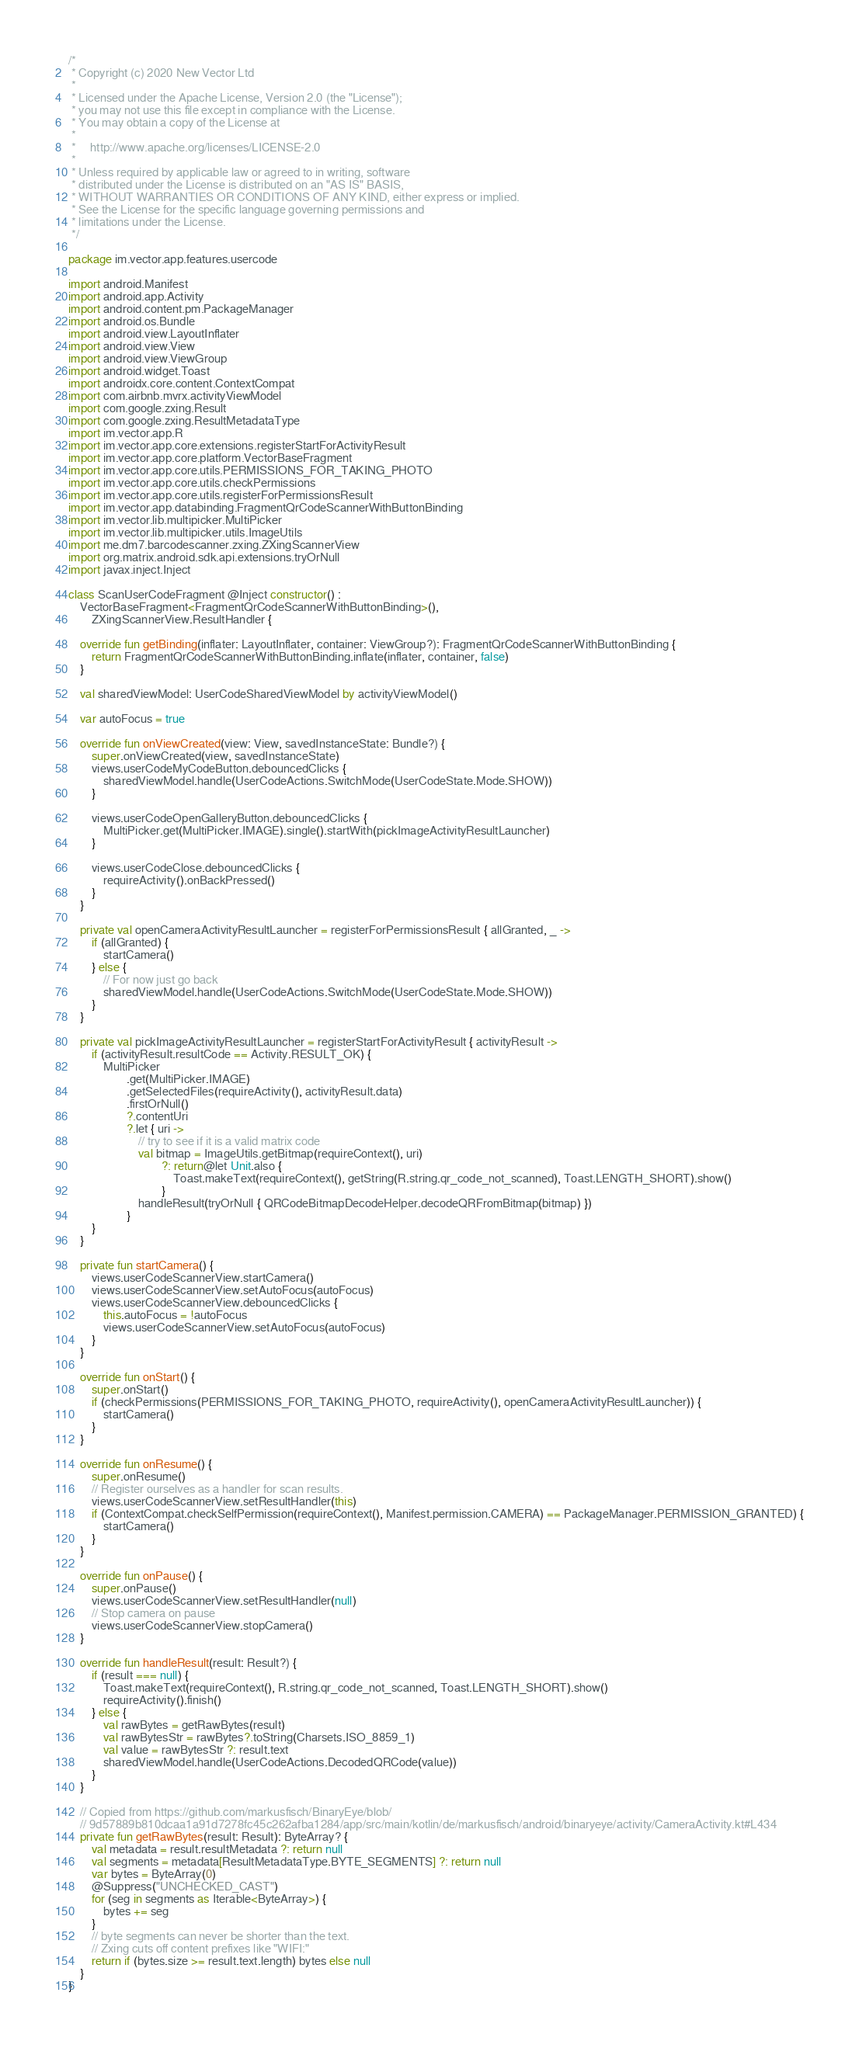<code> <loc_0><loc_0><loc_500><loc_500><_Kotlin_>/*
 * Copyright (c) 2020 New Vector Ltd
 *
 * Licensed under the Apache License, Version 2.0 (the "License");
 * you may not use this file except in compliance with the License.
 * You may obtain a copy of the License at
 *
 *     http://www.apache.org/licenses/LICENSE-2.0
 *
 * Unless required by applicable law or agreed to in writing, software
 * distributed under the License is distributed on an "AS IS" BASIS,
 * WITHOUT WARRANTIES OR CONDITIONS OF ANY KIND, either express or implied.
 * See the License for the specific language governing permissions and
 * limitations under the License.
 */

package im.vector.app.features.usercode

import android.Manifest
import android.app.Activity
import android.content.pm.PackageManager
import android.os.Bundle
import android.view.LayoutInflater
import android.view.View
import android.view.ViewGroup
import android.widget.Toast
import androidx.core.content.ContextCompat
import com.airbnb.mvrx.activityViewModel
import com.google.zxing.Result
import com.google.zxing.ResultMetadataType
import im.vector.app.R
import im.vector.app.core.extensions.registerStartForActivityResult
import im.vector.app.core.platform.VectorBaseFragment
import im.vector.app.core.utils.PERMISSIONS_FOR_TAKING_PHOTO
import im.vector.app.core.utils.checkPermissions
import im.vector.app.core.utils.registerForPermissionsResult
import im.vector.app.databinding.FragmentQrCodeScannerWithButtonBinding
import im.vector.lib.multipicker.MultiPicker
import im.vector.lib.multipicker.utils.ImageUtils
import me.dm7.barcodescanner.zxing.ZXingScannerView
import org.matrix.android.sdk.api.extensions.tryOrNull
import javax.inject.Inject

class ScanUserCodeFragment @Inject constructor() :
    VectorBaseFragment<FragmentQrCodeScannerWithButtonBinding>(),
        ZXingScannerView.ResultHandler {

    override fun getBinding(inflater: LayoutInflater, container: ViewGroup?): FragmentQrCodeScannerWithButtonBinding {
        return FragmentQrCodeScannerWithButtonBinding.inflate(inflater, container, false)
    }

    val sharedViewModel: UserCodeSharedViewModel by activityViewModel()

    var autoFocus = true

    override fun onViewCreated(view: View, savedInstanceState: Bundle?) {
        super.onViewCreated(view, savedInstanceState)
        views.userCodeMyCodeButton.debouncedClicks {
            sharedViewModel.handle(UserCodeActions.SwitchMode(UserCodeState.Mode.SHOW))
        }

        views.userCodeOpenGalleryButton.debouncedClicks {
            MultiPicker.get(MultiPicker.IMAGE).single().startWith(pickImageActivityResultLauncher)
        }

        views.userCodeClose.debouncedClicks {
            requireActivity().onBackPressed()
        }
    }

    private val openCameraActivityResultLauncher = registerForPermissionsResult { allGranted, _ ->
        if (allGranted) {
            startCamera()
        } else {
            // For now just go back
            sharedViewModel.handle(UserCodeActions.SwitchMode(UserCodeState.Mode.SHOW))
        }
    }

    private val pickImageActivityResultLauncher = registerStartForActivityResult { activityResult ->
        if (activityResult.resultCode == Activity.RESULT_OK) {
            MultiPicker
                    .get(MultiPicker.IMAGE)
                    .getSelectedFiles(requireActivity(), activityResult.data)
                    .firstOrNull()
                    ?.contentUri
                    ?.let { uri ->
                        // try to see if it is a valid matrix code
                        val bitmap = ImageUtils.getBitmap(requireContext(), uri)
                                ?: return@let Unit.also {
                                    Toast.makeText(requireContext(), getString(R.string.qr_code_not_scanned), Toast.LENGTH_SHORT).show()
                                }
                        handleResult(tryOrNull { QRCodeBitmapDecodeHelper.decodeQRFromBitmap(bitmap) })
                    }
        }
    }

    private fun startCamera() {
        views.userCodeScannerView.startCamera()
        views.userCodeScannerView.setAutoFocus(autoFocus)
        views.userCodeScannerView.debouncedClicks {
            this.autoFocus = !autoFocus
            views.userCodeScannerView.setAutoFocus(autoFocus)
        }
    }

    override fun onStart() {
        super.onStart()
        if (checkPermissions(PERMISSIONS_FOR_TAKING_PHOTO, requireActivity(), openCameraActivityResultLauncher)) {
            startCamera()
        }
    }

    override fun onResume() {
        super.onResume()
        // Register ourselves as a handler for scan results.
        views.userCodeScannerView.setResultHandler(this)
        if (ContextCompat.checkSelfPermission(requireContext(), Manifest.permission.CAMERA) == PackageManager.PERMISSION_GRANTED) {
            startCamera()
        }
    }

    override fun onPause() {
        super.onPause()
        views.userCodeScannerView.setResultHandler(null)
        // Stop camera on pause
        views.userCodeScannerView.stopCamera()
    }

    override fun handleResult(result: Result?) {
        if (result === null) {
            Toast.makeText(requireContext(), R.string.qr_code_not_scanned, Toast.LENGTH_SHORT).show()
            requireActivity().finish()
        } else {
            val rawBytes = getRawBytes(result)
            val rawBytesStr = rawBytes?.toString(Charsets.ISO_8859_1)
            val value = rawBytesStr ?: result.text
            sharedViewModel.handle(UserCodeActions.DecodedQRCode(value))
        }
    }

    // Copied from https://github.com/markusfisch/BinaryEye/blob/
    // 9d57889b810dcaa1a91d7278fc45c262afba1284/app/src/main/kotlin/de/markusfisch/android/binaryeye/activity/CameraActivity.kt#L434
    private fun getRawBytes(result: Result): ByteArray? {
        val metadata = result.resultMetadata ?: return null
        val segments = metadata[ResultMetadataType.BYTE_SEGMENTS] ?: return null
        var bytes = ByteArray(0)
        @Suppress("UNCHECKED_CAST")
        for (seg in segments as Iterable<ByteArray>) {
            bytes += seg
        }
        // byte segments can never be shorter than the text.
        // Zxing cuts off content prefixes like "WIFI:"
        return if (bytes.size >= result.text.length) bytes else null
    }
}
</code> 